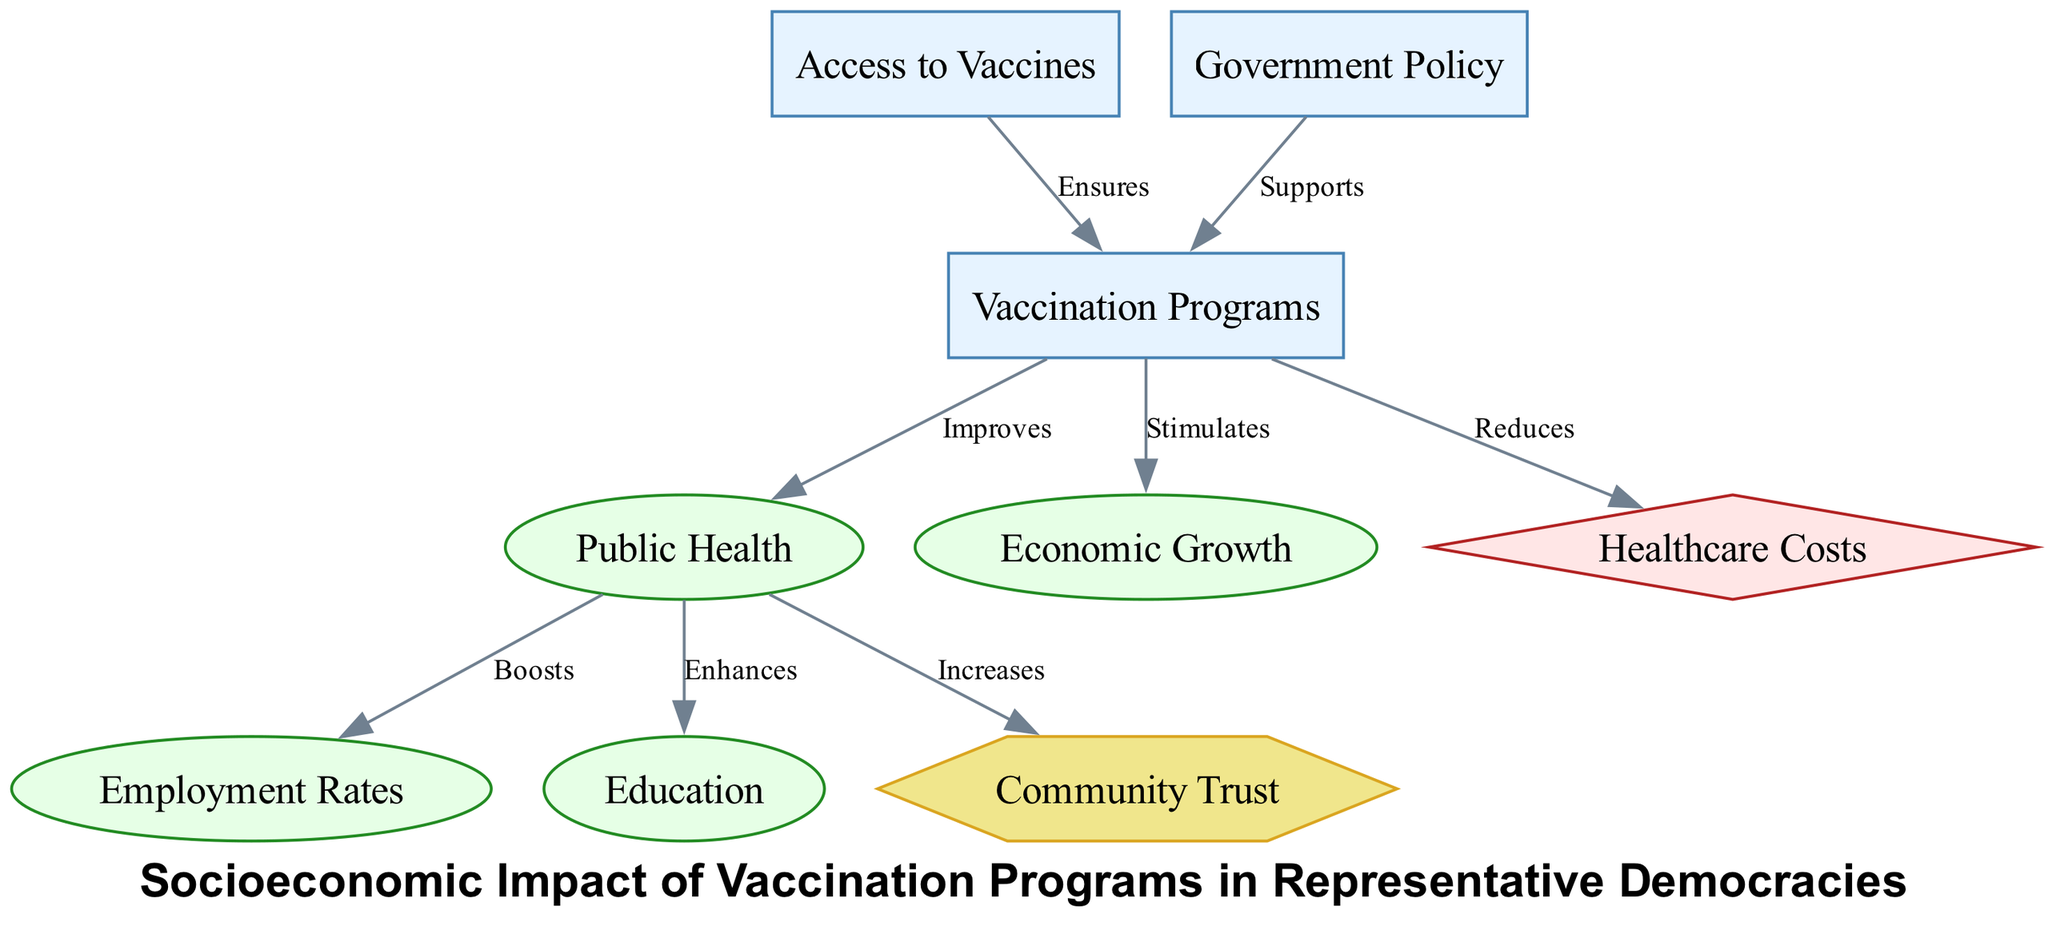What is the total number of nodes in the diagram? The diagram contains six nodes: Vaccination Programs, Public Health, Economic Growth, Employment Rates, Education, and Healthcare Costs. These represent different concepts related to the socioeconomic impact of vaccination programs.
Answer: 6 Which category does the node "Community Trust" belong to? In the diagram, "Community Trust" is categorized under "Social Impact". This can be determined by looking at the category assigned to each node.
Answer: Social Impact What relationship exists between "Vaccination Programs" and "Public Health"? The diagram specifies that "Vaccination Programs" improves "Public Health". This is indicated by a directed edge labeled "Improves" connecting the two nodes.
Answer: Improves How many edges are present in the diagram? The diagram has a total of seven edges, which represent the relationships among the nodes. Each edge connects a source node to a target node.
Answer: 7 What effect does "Public Health" have on "Education"? According to the diagram, "Public Health" enhances "Education". This relationship is represented by a directed edge labeled "Enhances" pointing from "Public Health" to "Education".
Answer: Enhances Which node is directly connected to "Healthcare Costs"? The node "Healthcare Costs" is directly connected to "Vaccination Programs" with the relationship labeled "Reduces". This indicates that vaccination programs have a reducing effect on healthcare costs.
Answer: Vaccination Programs What is the influence of "Government Policy" on "Vaccination Programs"? The diagram indicates that "Government Policy" supports "Vaccination Programs", showing a direct influence. The relationship is represented by an edge labeled "Supports".
Answer: Supports How does "Public Health" impact "Employment Rates"? The diagram shows that "Public Health" boosts "Employment Rates". This relationship is indicated by the directed edge labeled "Boosts" from "Public Health" to "Employment Rates".
Answer: Boosts What ensures "Access to Vaccines"? The node "Access to Vaccines" ensures "Vaccination Programs" in the diagram, as depicted by the directed edge with the label "Ensures". This suggests that access to vaccines is a prerequisite for vaccination programs to be effective.
Answer: Vaccination Programs What impact does "Public Health" have on "Community Trust"? The diagram shows that "Public Health" increases "Community Trust". This relationship is represented by a directed edge labeled "Increases" connecting the two nodes.
Answer: Increases 